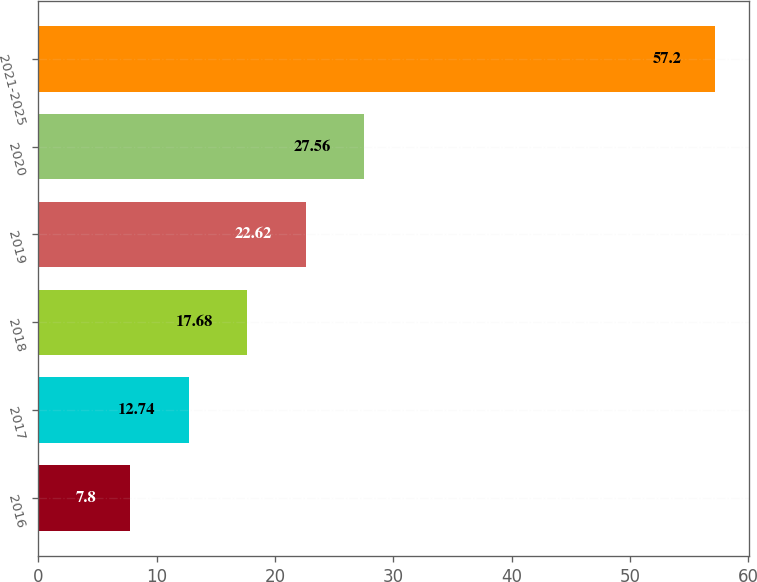Convert chart. <chart><loc_0><loc_0><loc_500><loc_500><bar_chart><fcel>2016<fcel>2017<fcel>2018<fcel>2019<fcel>2020<fcel>2021-2025<nl><fcel>7.8<fcel>12.74<fcel>17.68<fcel>22.62<fcel>27.56<fcel>57.2<nl></chart> 